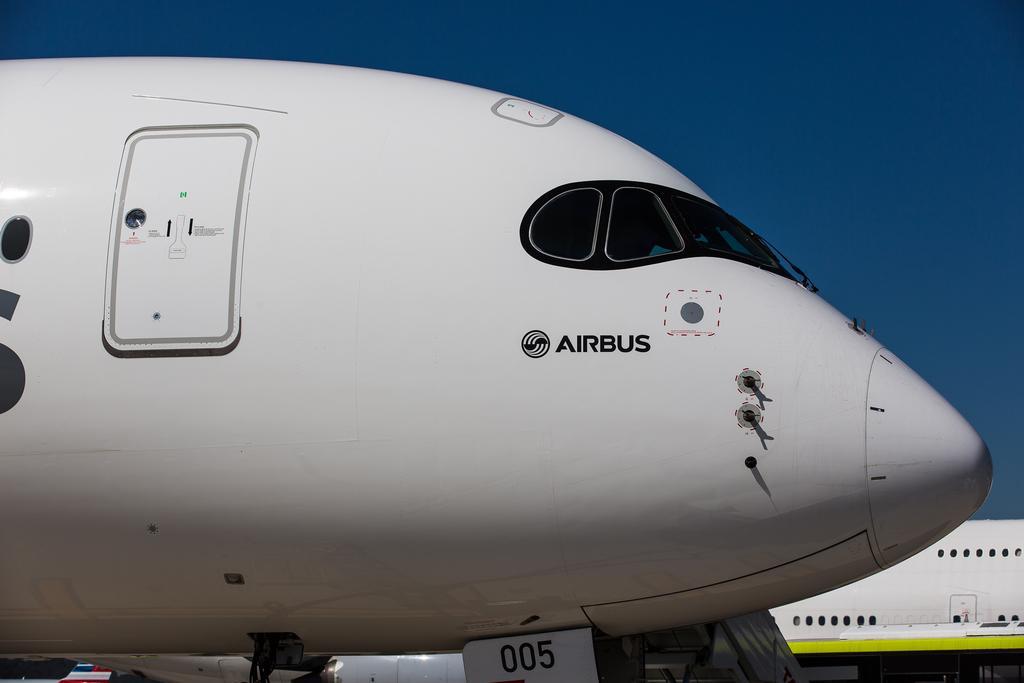Can you describe this image briefly? In this picture we can see airplanes which are truncated. In the background there is sky. 